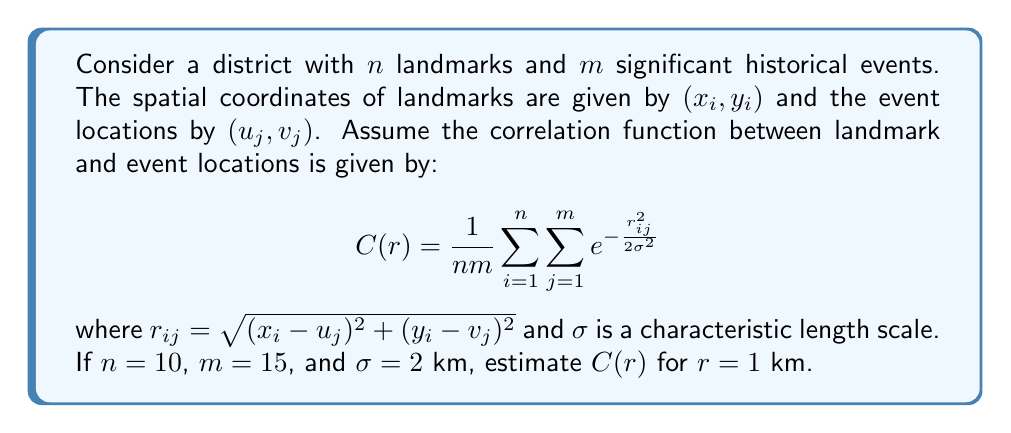Solve this math problem. To estimate the correlation function $C(r)$ for $r = 1$ km, we need to follow these steps:

1) First, we note that the correlation function is an average over all landmark-event pairs:

   $$C(r) = \frac{1}{nm} \sum_{i=1}^n \sum_{j=1}^m e^{-\frac{r_{ij}^2}{2\sigma^2}}$$

2) We are given that $n = 10$ landmarks and $m = 15$ events, so $nm = 150$.

3) The characteristic length scale $\sigma = 2$ km.

4) We want to estimate $C(r)$ for $r = 1$ km. This means we're assuming all landmark-event pairs are separated by exactly 1 km. In reality, the distances would vary, but this simplification allows us to estimate the correlation.

5) Substituting these values into the exponential term:

   $$e^{-\frac{r_{ij}^2}{2\sigma^2}} = e^{-\frac{1^2}{2(2^2)}} = e^{-\frac{1}{8}} \approx 0.8825$$

6) Since we're assuming all pairs have the same separation, the sum becomes simply $nm$ times this value:

   $$C(1) = \frac{1}{nm} \cdot nm \cdot e^{-\frac{1}{8}} = e^{-\frac{1}{8}} \approx 0.8825$$

Thus, our estimate for $C(1)$ is approximately 0.8825.
Answer: $C(1) \approx 0.8825$ 